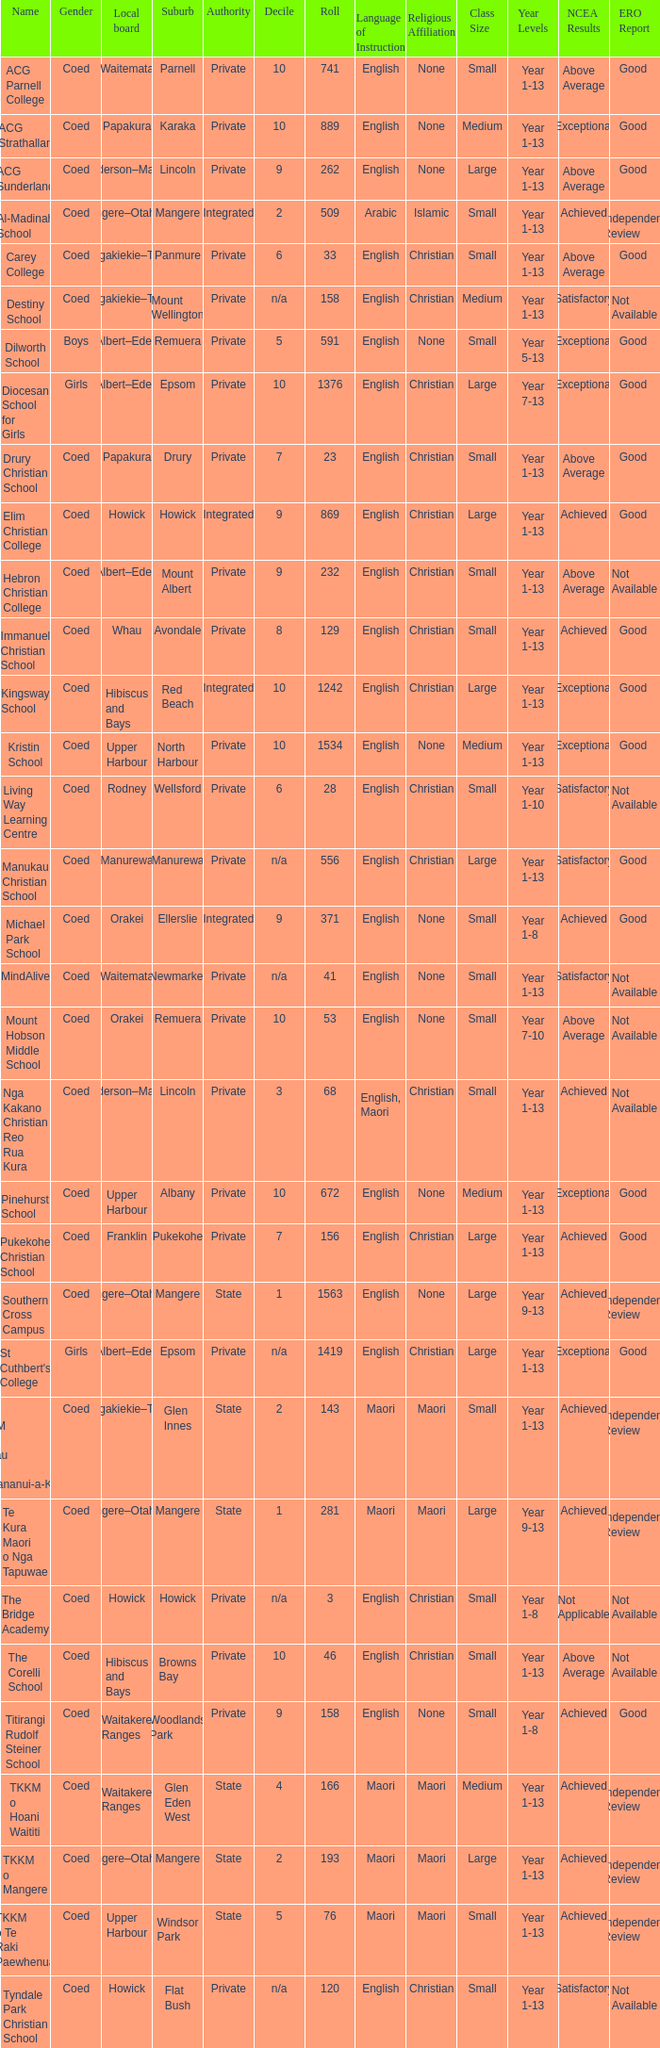What gender has a local board of albert–eden with a roll of more than 232 and Decile of 5? Boys. 